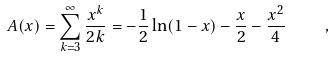Convert formula to latex. <formula><loc_0><loc_0><loc_500><loc_500>A ( x ) = \sum _ { k = 3 } ^ { \infty } \frac { x ^ { k } } { 2 k } = - \frac { 1 } { 2 } \ln ( 1 - x ) - \frac { x } { 2 } - \frac { x ^ { 2 } } { 4 } \quad ,</formula> 